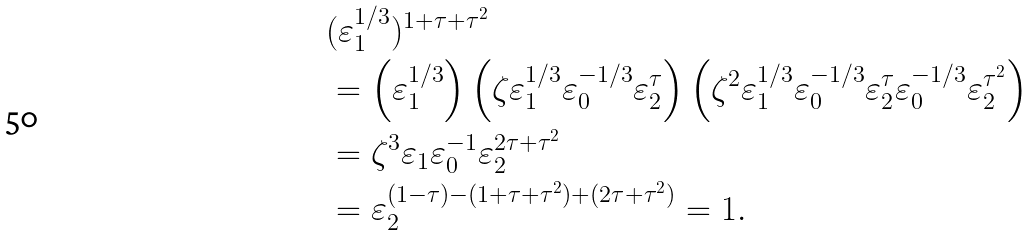<formula> <loc_0><loc_0><loc_500><loc_500>& ( \varepsilon _ { 1 } ^ { 1 / 3 } ) ^ { 1 + \tau + \tau ^ { 2 } } \\ & = \left ( \varepsilon _ { 1 } ^ { 1 / 3 } \right ) \left ( \zeta \varepsilon _ { 1 } ^ { 1 / 3 } \varepsilon _ { 0 } ^ { - 1 / 3 } \varepsilon _ { 2 } ^ { \tau } \right ) \left ( \zeta ^ { 2 } \varepsilon _ { 1 } ^ { 1 / 3 } \varepsilon _ { 0 } ^ { - 1 / 3 } \varepsilon _ { 2 } ^ { \tau } \varepsilon _ { 0 } ^ { - 1 / 3 } \varepsilon _ { 2 } ^ { \tau ^ { 2 } } \right ) \\ & = \zeta ^ { 3 } \varepsilon _ { 1 } \varepsilon _ { 0 } ^ { - 1 } \varepsilon _ { 2 } ^ { 2 \tau + \tau ^ { 2 } } \\ & = \varepsilon _ { 2 } ^ { ( 1 - \tau ) - ( 1 + \tau + \tau ^ { 2 } ) + ( 2 \tau + \tau ^ { 2 } ) } = 1 .</formula> 